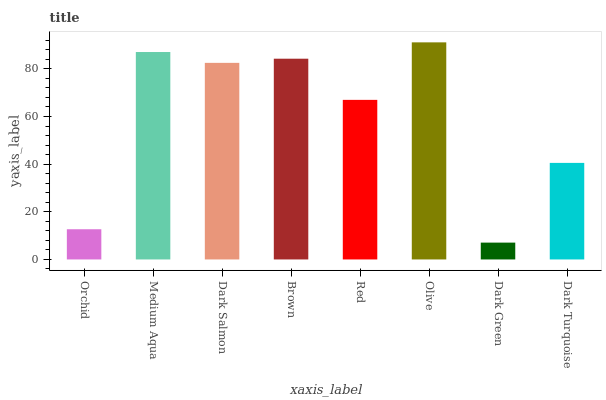Is Dark Green the minimum?
Answer yes or no. Yes. Is Olive the maximum?
Answer yes or no. Yes. Is Medium Aqua the minimum?
Answer yes or no. No. Is Medium Aqua the maximum?
Answer yes or no. No. Is Medium Aqua greater than Orchid?
Answer yes or no. Yes. Is Orchid less than Medium Aqua?
Answer yes or no. Yes. Is Orchid greater than Medium Aqua?
Answer yes or no. No. Is Medium Aqua less than Orchid?
Answer yes or no. No. Is Dark Salmon the high median?
Answer yes or no. Yes. Is Red the low median?
Answer yes or no. Yes. Is Olive the high median?
Answer yes or no. No. Is Dark Turquoise the low median?
Answer yes or no. No. 